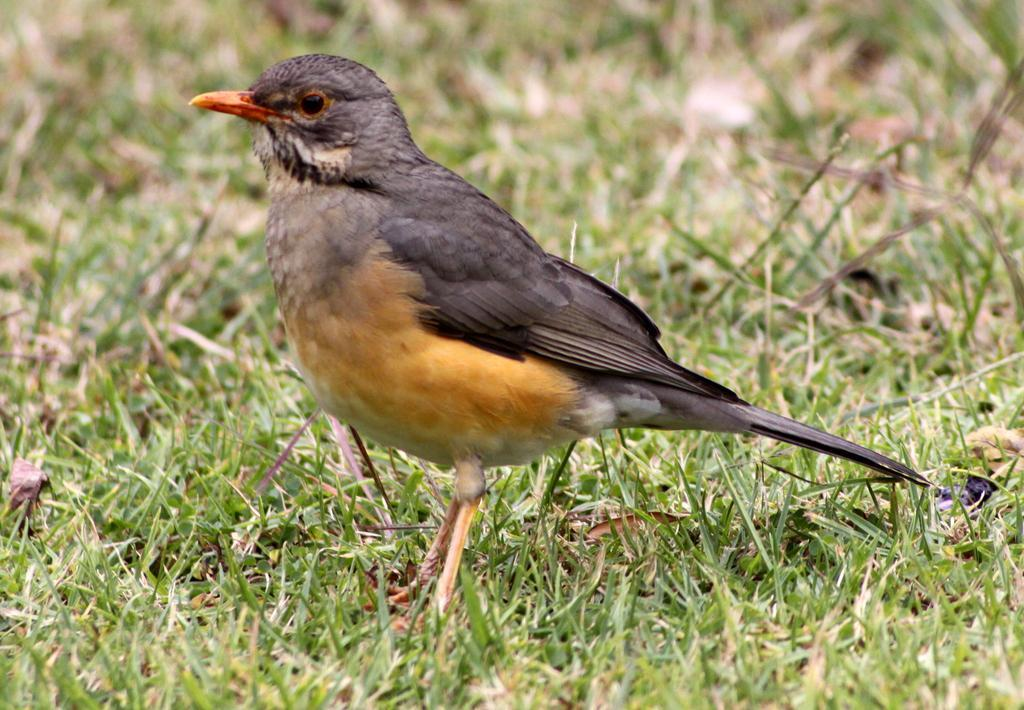What type of animal can be seen in the image? There is a bird in the image. What type of vegetation is visible in the image? There is grass visible in the image. What is the price of the orange in the bird's mouth in the image? There is no orange or mouth present in the image; it features a bird and grass. 